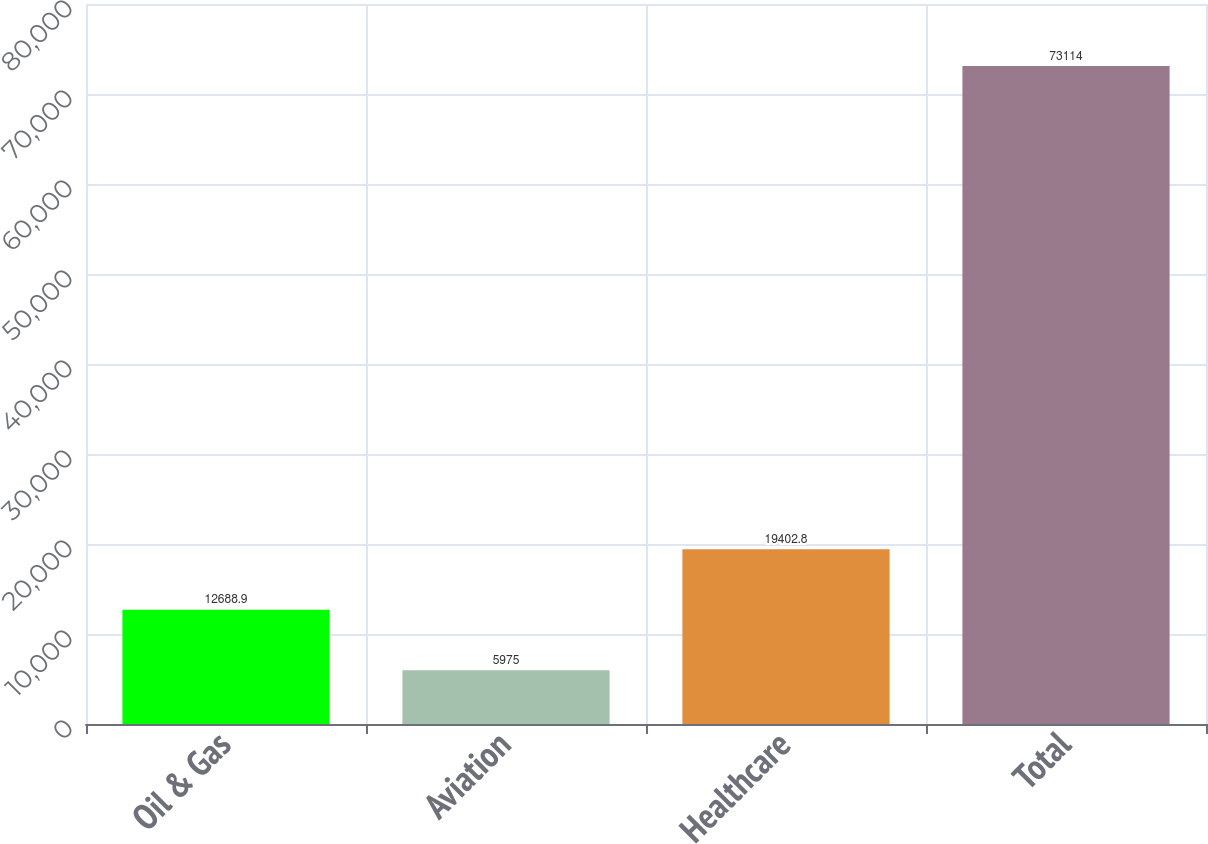Convert chart to OTSL. <chart><loc_0><loc_0><loc_500><loc_500><bar_chart><fcel>Oil & Gas<fcel>Aviation<fcel>Healthcare<fcel>Total<nl><fcel>12688.9<fcel>5975<fcel>19402.8<fcel>73114<nl></chart> 